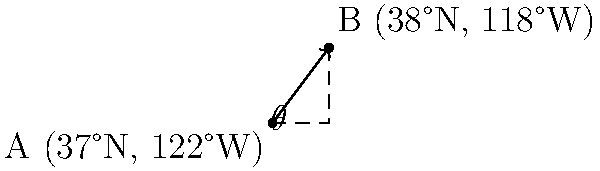Two UFO sightings were reported at different locations. Sighting A occurred at 37°N latitude and 122°W longitude, while sighting B occurred at 38°N latitude and 118°W longitude. Calculate the angle $\theta$ between these two locations as seen from the center of the Earth, assuming a spherical Earth model. To calculate the angle between two points on a sphere, we can use the great circle distance formula:

1) Convert the latitudes and longitudes to radians:
   $\text{lat}_1 = 37° \cdot \frac{\pi}{180} = 0.6458$ rad
   $\text{lon}_1 = -122° \cdot \frac{\pi}{180} = -2.1293$ rad
   $\text{lat}_2 = 38° \cdot \frac{\pi}{180} = 0.6632$ rad
   $\text{lon}_2 = -118° \cdot \frac{\pi}{180} = -2.0594$ rad

2) Calculate the difference in longitude:
   $\Delta\text{lon} = \text{lon}_2 - \text{lon}_1 = 0.0699$ rad

3) Apply the great circle distance formula:
   $\theta = \arccos(\sin(\text{lat}_1) \cdot \sin(\text{lat}_2) + \cos(\text{lat}_1) \cdot \cos(\text{lat}_2) \cdot \cos(\Delta\text{lon}))$

4) Substitute the values:
   $\theta = \arccos(\sin(0.6458) \cdot \sin(0.6632) + \cos(0.6458) \cdot \cos(0.6632) \cdot \cos(0.0699))$

5) Calculate:
   $\theta = 0.0733$ rad

6) Convert to degrees:
   $\theta = 0.0733 \cdot \frac{180}{\pi} = 4.20°$

Therefore, the angle between the two UFO sighting locations is approximately 4.20°.
Answer: 4.20° 